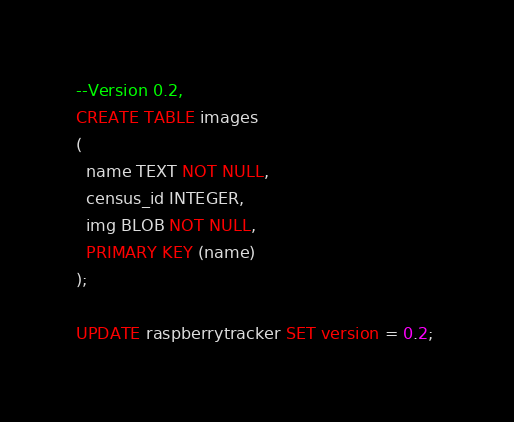Convert code to text. <code><loc_0><loc_0><loc_500><loc_500><_SQL_>--Version 0.2, 
CREATE TABLE images
(
  name TEXT NOT NULL,
  census_id INTEGER,
  img BLOB NOT NULL, 
  PRIMARY KEY (name)
);

UPDATE raspberrytracker SET version = 0.2; 
</code> 